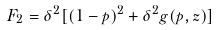<formula> <loc_0><loc_0><loc_500><loc_500>F _ { 2 } = \delta ^ { 2 } [ ( 1 - p ) ^ { 2 } + \delta ^ { 2 } g ( p , z ) ]</formula> 